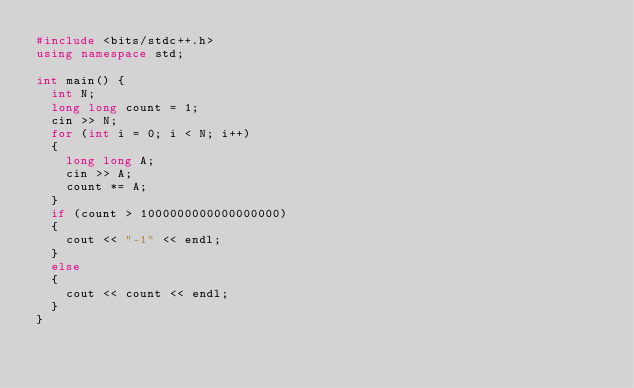Convert code to text. <code><loc_0><loc_0><loc_500><loc_500><_C++_>#include <bits/stdc++.h>
using namespace std;

int main() {
  int N;
  long long count = 1;
  cin >> N;
  for (int i = 0; i < N; i++)
  {
    long long A;
    cin >> A;
    count *= A;
  }
  if (count > 1000000000000000000)
  {
    cout << "-1" << endl;
  }
  else
  {
    cout << count << endl;
  }
}</code> 